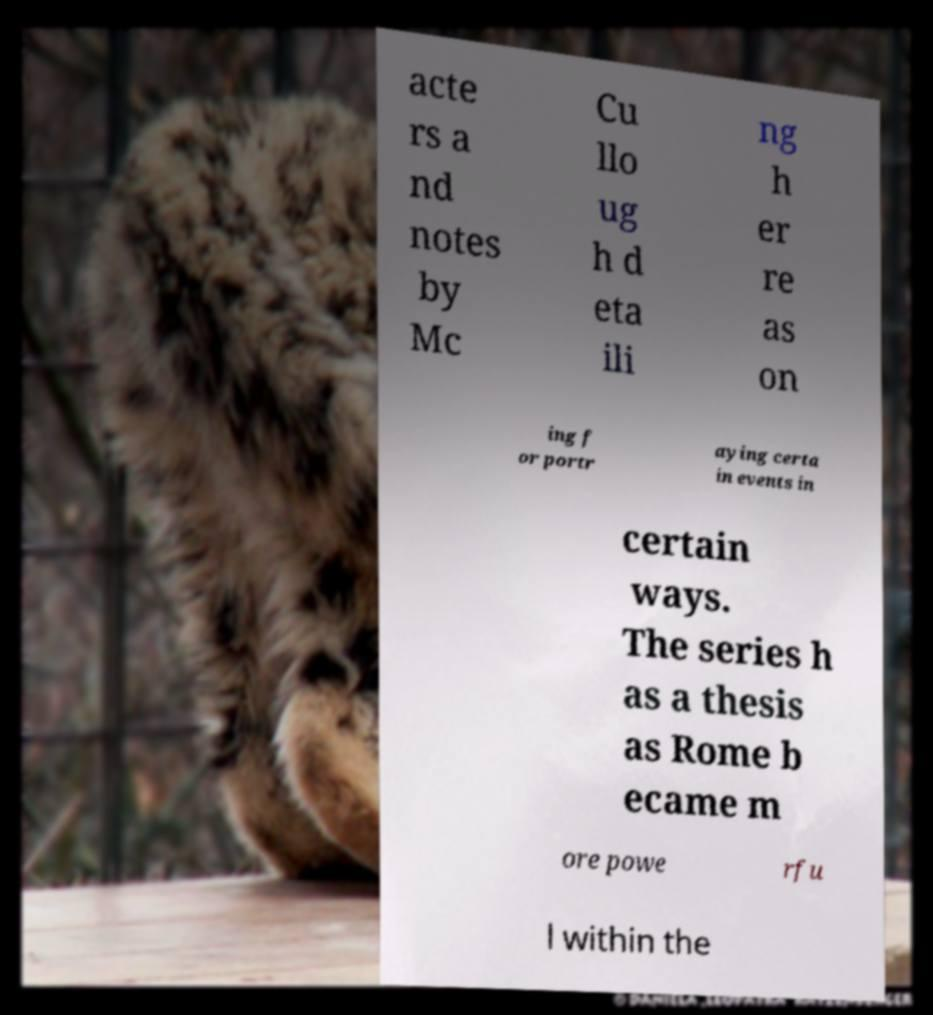I need the written content from this picture converted into text. Can you do that? acte rs a nd notes by Mc Cu llo ug h d eta ili ng h er re as on ing f or portr aying certa in events in certain ways. The series h as a thesis as Rome b ecame m ore powe rfu l within the 